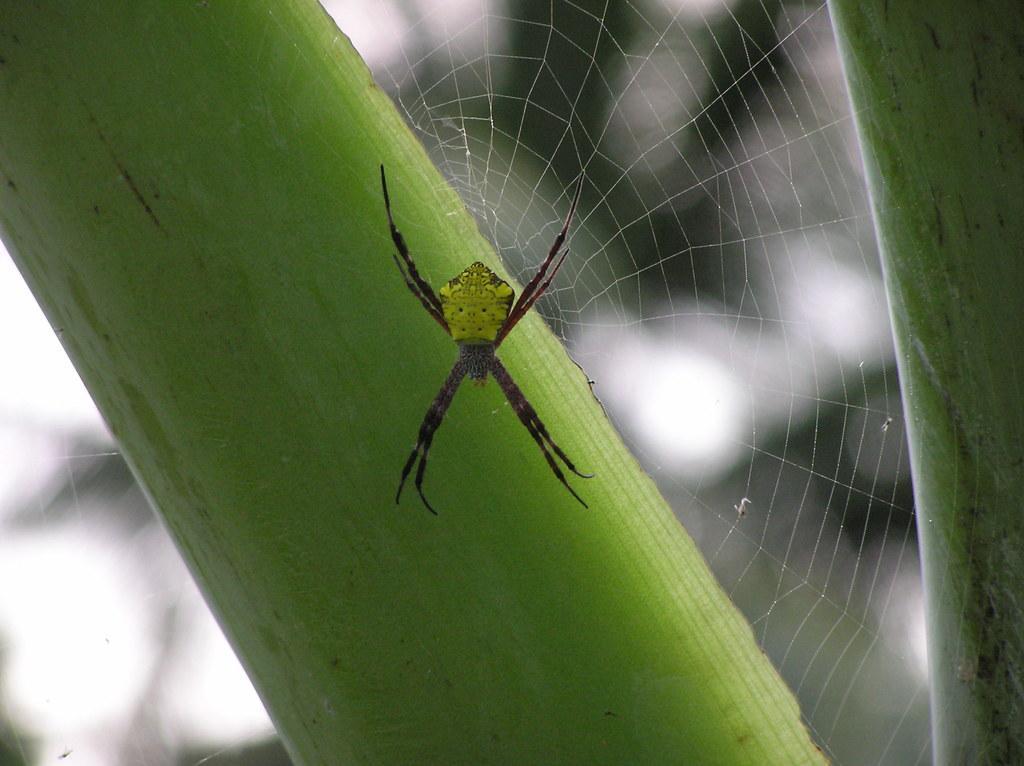Can you describe this image briefly? In this image there is a spider and a spider web on a plant and there is a blurred background. 